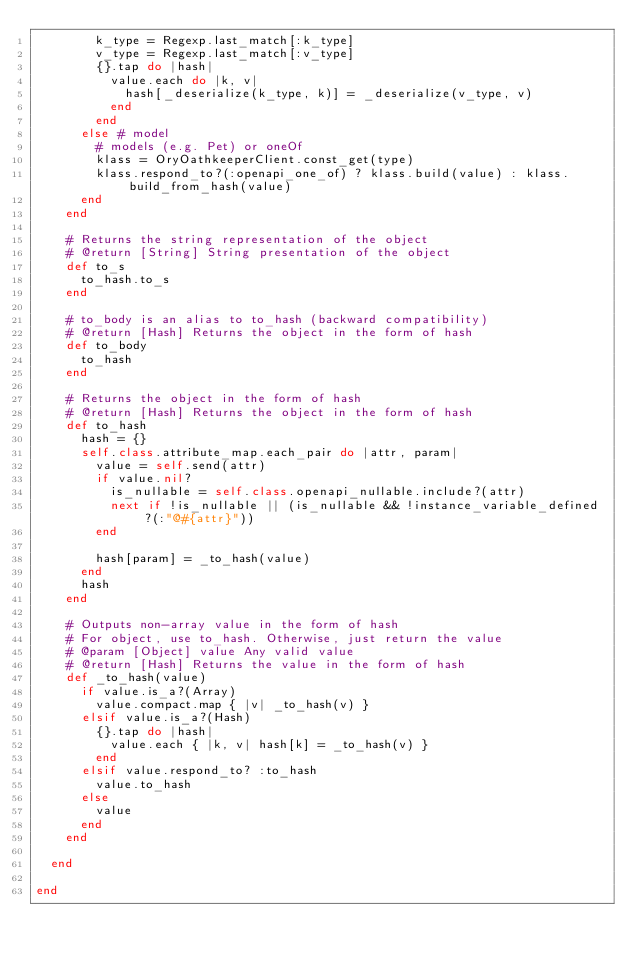<code> <loc_0><loc_0><loc_500><loc_500><_Ruby_>        k_type = Regexp.last_match[:k_type]
        v_type = Regexp.last_match[:v_type]
        {}.tap do |hash|
          value.each do |k, v|
            hash[_deserialize(k_type, k)] = _deserialize(v_type, v)
          end
        end
      else # model
        # models (e.g. Pet) or oneOf
        klass = OryOathkeeperClient.const_get(type)
        klass.respond_to?(:openapi_one_of) ? klass.build(value) : klass.build_from_hash(value)
      end
    end

    # Returns the string representation of the object
    # @return [String] String presentation of the object
    def to_s
      to_hash.to_s
    end

    # to_body is an alias to to_hash (backward compatibility)
    # @return [Hash] Returns the object in the form of hash
    def to_body
      to_hash
    end

    # Returns the object in the form of hash
    # @return [Hash] Returns the object in the form of hash
    def to_hash
      hash = {}
      self.class.attribute_map.each_pair do |attr, param|
        value = self.send(attr)
        if value.nil?
          is_nullable = self.class.openapi_nullable.include?(attr)
          next if !is_nullable || (is_nullable && !instance_variable_defined?(:"@#{attr}"))
        end

        hash[param] = _to_hash(value)
      end
      hash
    end

    # Outputs non-array value in the form of hash
    # For object, use to_hash. Otherwise, just return the value
    # @param [Object] value Any valid value
    # @return [Hash] Returns the value in the form of hash
    def _to_hash(value)
      if value.is_a?(Array)
        value.compact.map { |v| _to_hash(v) }
      elsif value.is_a?(Hash)
        {}.tap do |hash|
          value.each { |k, v| hash[k] = _to_hash(v) }
        end
      elsif value.respond_to? :to_hash
        value.to_hash
      else
        value
      end
    end

  end

end
</code> 